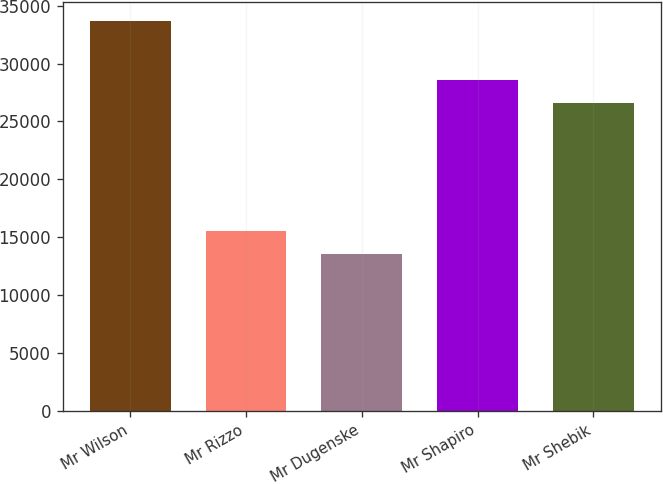<chart> <loc_0><loc_0><loc_500><loc_500><bar_chart><fcel>Mr Wilson<fcel>Mr Rizzo<fcel>Mr Dugenske<fcel>Mr Shapiro<fcel>Mr Shebik<nl><fcel>33640<fcel>15568<fcel>13560<fcel>28568<fcel>26560<nl></chart> 